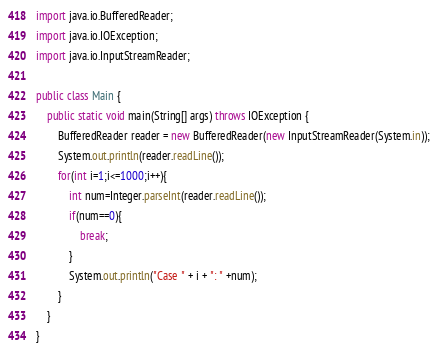<code> <loc_0><loc_0><loc_500><loc_500><_Java_>import java.io.BufferedReader;
import java.io.IOException;
import java.io.InputStreamReader;

public class Main {
	public static void main(String[] args) throws IOException {
        BufferedReader reader = new BufferedReader(new InputStreamReader(System.in));
        System.out.println(reader.readLine());
        for(int i=1;i<=1000;i++){
            int num=Integer.parseInt(reader.readLine());
            if(num==0){
            	break;
            }
        	System.out.println("Case " + i + ": " +num);
        }
	}
}</code> 